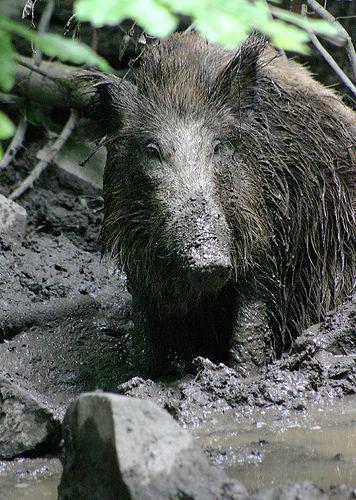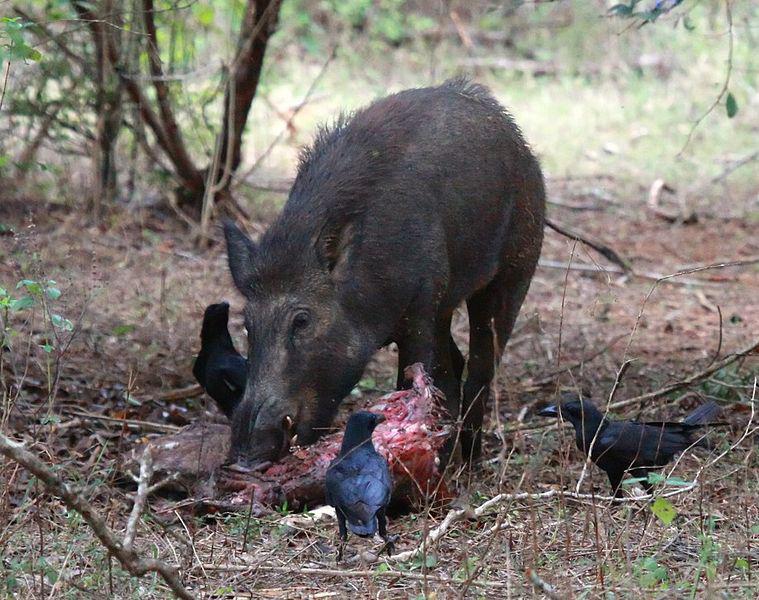The first image is the image on the left, the second image is the image on the right. Given the left and right images, does the statement "One image shows a boar standing in the mud." hold true? Answer yes or no. Yes. 